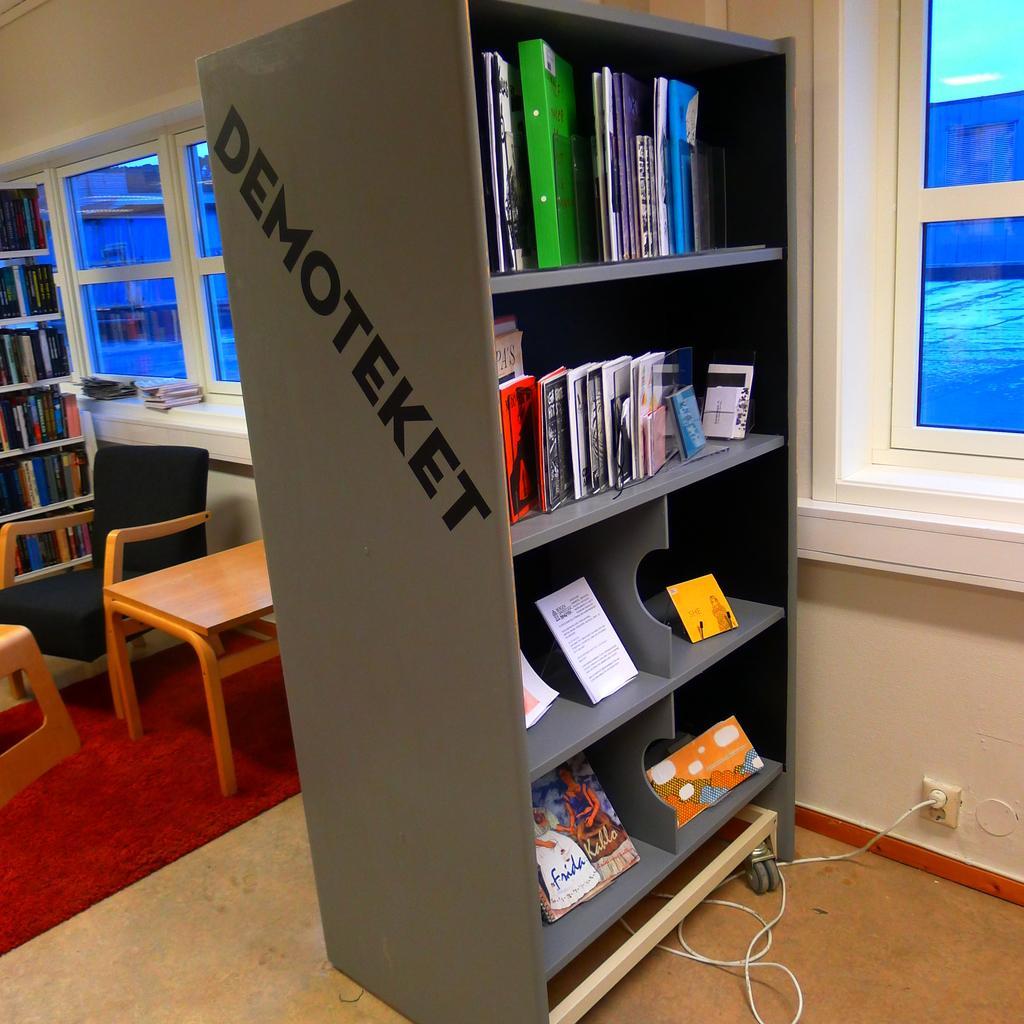Can you describe this image briefly? This image is clicked inside a room. In the foreground there is a rack. There are books in the rack. Behind the rack there are tables and chairs. To the right there is a wall. There are glass windows to the wall. In the background there is another rack. There are books in that rack. There are books near the window. There is a carpet on the floor. In the bottom right there is an adapter to the power socket. 